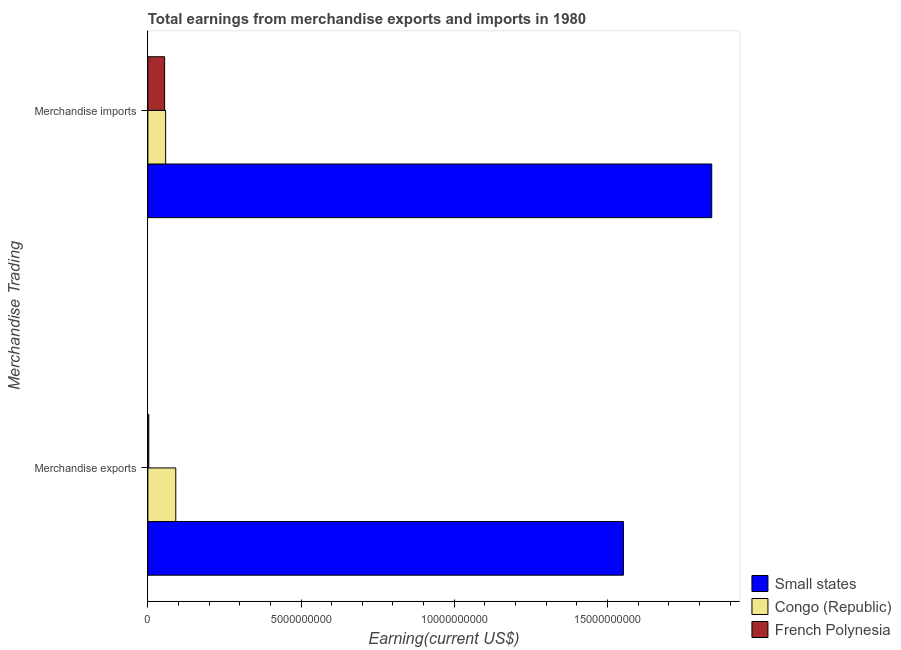How many different coloured bars are there?
Offer a very short reply. 3. How many groups of bars are there?
Keep it short and to the point. 2. Are the number of bars on each tick of the Y-axis equal?
Keep it short and to the point. Yes. What is the earnings from merchandise exports in French Polynesia?
Offer a very short reply. 3.00e+07. Across all countries, what is the maximum earnings from merchandise exports?
Provide a succinct answer. 1.55e+1. Across all countries, what is the minimum earnings from merchandise imports?
Your answer should be very brief. 5.47e+08. In which country was the earnings from merchandise imports maximum?
Your answer should be very brief. Small states. In which country was the earnings from merchandise imports minimum?
Your answer should be very brief. French Polynesia. What is the total earnings from merchandise imports in the graph?
Provide a short and direct response. 1.95e+1. What is the difference between the earnings from merchandise imports in French Polynesia and that in Congo (Republic)?
Your answer should be very brief. -3.30e+07. What is the difference between the earnings from merchandise imports in French Polynesia and the earnings from merchandise exports in Congo (Republic)?
Your response must be concise. -3.64e+08. What is the average earnings from merchandise exports per country?
Provide a short and direct response. 5.49e+09. What is the difference between the earnings from merchandise exports and earnings from merchandise imports in French Polynesia?
Your response must be concise. -5.17e+08. What is the ratio of the earnings from merchandise imports in Congo (Republic) to that in Small states?
Provide a short and direct response. 0.03. In how many countries, is the earnings from merchandise imports greater than the average earnings from merchandise imports taken over all countries?
Give a very brief answer. 1. What does the 3rd bar from the top in Merchandise imports represents?
Your answer should be very brief. Small states. What does the 3rd bar from the bottom in Merchandise exports represents?
Provide a succinct answer. French Polynesia. Are all the bars in the graph horizontal?
Offer a terse response. Yes. How many countries are there in the graph?
Provide a short and direct response. 3. What is the difference between two consecutive major ticks on the X-axis?
Give a very brief answer. 5.00e+09. Are the values on the major ticks of X-axis written in scientific E-notation?
Your answer should be compact. No. Where does the legend appear in the graph?
Your response must be concise. Bottom right. What is the title of the graph?
Ensure brevity in your answer.  Total earnings from merchandise exports and imports in 1980. What is the label or title of the X-axis?
Provide a short and direct response. Earning(current US$). What is the label or title of the Y-axis?
Offer a terse response. Merchandise Trading. What is the Earning(current US$) of Small states in Merchandise exports?
Ensure brevity in your answer.  1.55e+1. What is the Earning(current US$) in Congo (Republic) in Merchandise exports?
Offer a terse response. 9.11e+08. What is the Earning(current US$) in French Polynesia in Merchandise exports?
Make the answer very short. 3.00e+07. What is the Earning(current US$) of Small states in Merchandise imports?
Give a very brief answer. 1.84e+1. What is the Earning(current US$) of Congo (Republic) in Merchandise imports?
Ensure brevity in your answer.  5.80e+08. What is the Earning(current US$) in French Polynesia in Merchandise imports?
Provide a short and direct response. 5.47e+08. Across all Merchandise Trading, what is the maximum Earning(current US$) of Small states?
Give a very brief answer. 1.84e+1. Across all Merchandise Trading, what is the maximum Earning(current US$) of Congo (Republic)?
Your answer should be compact. 9.11e+08. Across all Merchandise Trading, what is the maximum Earning(current US$) of French Polynesia?
Ensure brevity in your answer.  5.47e+08. Across all Merchandise Trading, what is the minimum Earning(current US$) in Small states?
Make the answer very short. 1.55e+1. Across all Merchandise Trading, what is the minimum Earning(current US$) in Congo (Republic)?
Offer a very short reply. 5.80e+08. Across all Merchandise Trading, what is the minimum Earning(current US$) of French Polynesia?
Ensure brevity in your answer.  3.00e+07. What is the total Earning(current US$) in Small states in the graph?
Offer a terse response. 3.39e+1. What is the total Earning(current US$) of Congo (Republic) in the graph?
Offer a very short reply. 1.49e+09. What is the total Earning(current US$) in French Polynesia in the graph?
Provide a succinct answer. 5.77e+08. What is the difference between the Earning(current US$) in Small states in Merchandise exports and that in Merchandise imports?
Offer a terse response. -2.88e+09. What is the difference between the Earning(current US$) of Congo (Republic) in Merchandise exports and that in Merchandise imports?
Provide a short and direct response. 3.31e+08. What is the difference between the Earning(current US$) of French Polynesia in Merchandise exports and that in Merchandise imports?
Provide a short and direct response. -5.17e+08. What is the difference between the Earning(current US$) of Small states in Merchandise exports and the Earning(current US$) of Congo (Republic) in Merchandise imports?
Offer a very short reply. 1.49e+1. What is the difference between the Earning(current US$) of Small states in Merchandise exports and the Earning(current US$) of French Polynesia in Merchandise imports?
Your response must be concise. 1.50e+1. What is the difference between the Earning(current US$) of Congo (Republic) in Merchandise exports and the Earning(current US$) of French Polynesia in Merchandise imports?
Ensure brevity in your answer.  3.64e+08. What is the average Earning(current US$) in Small states per Merchandise Trading?
Your answer should be compact. 1.70e+1. What is the average Earning(current US$) in Congo (Republic) per Merchandise Trading?
Give a very brief answer. 7.46e+08. What is the average Earning(current US$) of French Polynesia per Merchandise Trading?
Your answer should be very brief. 2.88e+08. What is the difference between the Earning(current US$) in Small states and Earning(current US$) in Congo (Republic) in Merchandise exports?
Your response must be concise. 1.46e+1. What is the difference between the Earning(current US$) in Small states and Earning(current US$) in French Polynesia in Merchandise exports?
Offer a very short reply. 1.55e+1. What is the difference between the Earning(current US$) in Congo (Republic) and Earning(current US$) in French Polynesia in Merchandise exports?
Ensure brevity in your answer.  8.81e+08. What is the difference between the Earning(current US$) in Small states and Earning(current US$) in Congo (Republic) in Merchandise imports?
Offer a terse response. 1.78e+1. What is the difference between the Earning(current US$) in Small states and Earning(current US$) in French Polynesia in Merchandise imports?
Provide a short and direct response. 1.79e+1. What is the difference between the Earning(current US$) of Congo (Republic) and Earning(current US$) of French Polynesia in Merchandise imports?
Your answer should be very brief. 3.30e+07. What is the ratio of the Earning(current US$) in Small states in Merchandise exports to that in Merchandise imports?
Keep it short and to the point. 0.84. What is the ratio of the Earning(current US$) of Congo (Republic) in Merchandise exports to that in Merchandise imports?
Your response must be concise. 1.57. What is the ratio of the Earning(current US$) of French Polynesia in Merchandise exports to that in Merchandise imports?
Ensure brevity in your answer.  0.05. What is the difference between the highest and the second highest Earning(current US$) in Small states?
Your response must be concise. 2.88e+09. What is the difference between the highest and the second highest Earning(current US$) in Congo (Republic)?
Provide a short and direct response. 3.31e+08. What is the difference between the highest and the second highest Earning(current US$) in French Polynesia?
Ensure brevity in your answer.  5.17e+08. What is the difference between the highest and the lowest Earning(current US$) in Small states?
Make the answer very short. 2.88e+09. What is the difference between the highest and the lowest Earning(current US$) in Congo (Republic)?
Ensure brevity in your answer.  3.31e+08. What is the difference between the highest and the lowest Earning(current US$) in French Polynesia?
Give a very brief answer. 5.17e+08. 